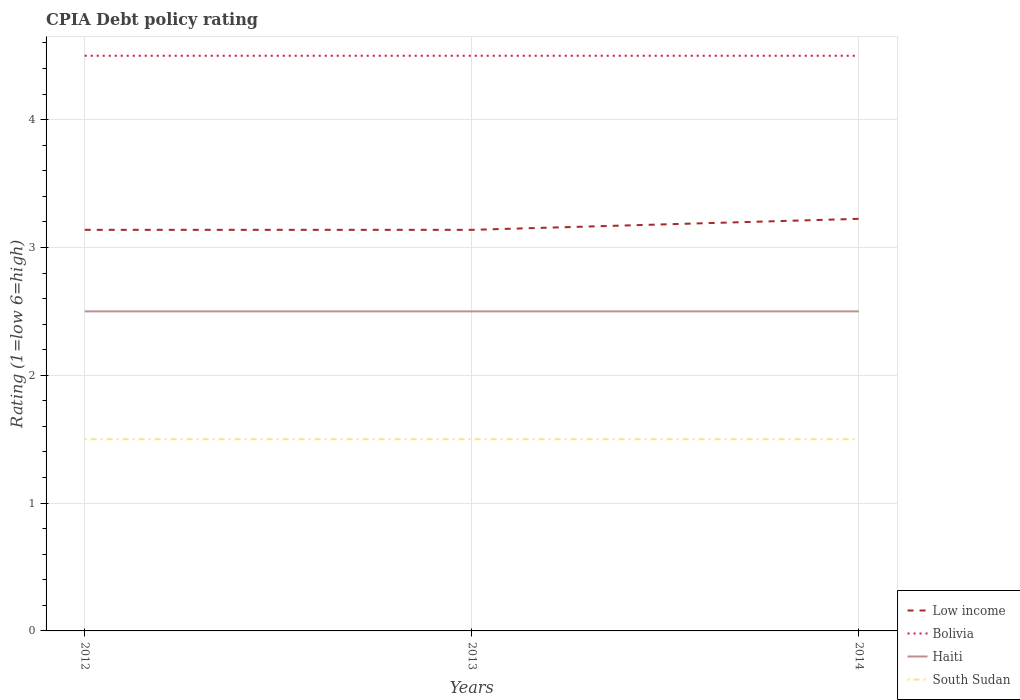Is the number of lines equal to the number of legend labels?
Keep it short and to the point. Yes. Across all years, what is the maximum CPIA rating in South Sudan?
Make the answer very short. 1.5. What is the difference between the highest and the lowest CPIA rating in Bolivia?
Give a very brief answer. 0. Is the CPIA rating in South Sudan strictly greater than the CPIA rating in Bolivia over the years?
Offer a very short reply. Yes. What is the difference between two consecutive major ticks on the Y-axis?
Make the answer very short. 1. Does the graph contain any zero values?
Provide a short and direct response. No. Does the graph contain grids?
Offer a very short reply. Yes. Where does the legend appear in the graph?
Keep it short and to the point. Bottom right. How many legend labels are there?
Your answer should be compact. 4. How are the legend labels stacked?
Your answer should be compact. Vertical. What is the title of the graph?
Offer a terse response. CPIA Debt policy rating. What is the label or title of the X-axis?
Ensure brevity in your answer.  Years. What is the Rating (1=low 6=high) in Low income in 2012?
Your answer should be very brief. 3.14. What is the Rating (1=low 6=high) in Haiti in 2012?
Ensure brevity in your answer.  2.5. What is the Rating (1=low 6=high) in South Sudan in 2012?
Your answer should be compact. 1.5. What is the Rating (1=low 6=high) in Low income in 2013?
Your answer should be very brief. 3.14. What is the Rating (1=low 6=high) of Bolivia in 2013?
Offer a very short reply. 4.5. What is the Rating (1=low 6=high) in Haiti in 2013?
Your answer should be compact. 2.5. What is the Rating (1=low 6=high) in South Sudan in 2013?
Keep it short and to the point. 1.5. What is the Rating (1=low 6=high) of Low income in 2014?
Your answer should be very brief. 3.22. Across all years, what is the maximum Rating (1=low 6=high) of Low income?
Your answer should be compact. 3.22. Across all years, what is the maximum Rating (1=low 6=high) in Bolivia?
Your answer should be compact. 4.5. Across all years, what is the maximum Rating (1=low 6=high) of Haiti?
Keep it short and to the point. 2.5. Across all years, what is the maximum Rating (1=low 6=high) in South Sudan?
Your answer should be compact. 1.5. Across all years, what is the minimum Rating (1=low 6=high) in Low income?
Offer a very short reply. 3.14. Across all years, what is the minimum Rating (1=low 6=high) of South Sudan?
Offer a terse response. 1.5. What is the total Rating (1=low 6=high) in Low income in the graph?
Provide a short and direct response. 9.5. What is the total Rating (1=low 6=high) of Haiti in the graph?
Ensure brevity in your answer.  7.5. What is the difference between the Rating (1=low 6=high) of Low income in 2012 and that in 2013?
Ensure brevity in your answer.  0. What is the difference between the Rating (1=low 6=high) in Bolivia in 2012 and that in 2013?
Make the answer very short. 0. What is the difference between the Rating (1=low 6=high) in Haiti in 2012 and that in 2013?
Keep it short and to the point. 0. What is the difference between the Rating (1=low 6=high) in South Sudan in 2012 and that in 2013?
Offer a terse response. 0. What is the difference between the Rating (1=low 6=high) of Low income in 2012 and that in 2014?
Provide a succinct answer. -0.09. What is the difference between the Rating (1=low 6=high) in Bolivia in 2012 and that in 2014?
Your answer should be very brief. 0. What is the difference between the Rating (1=low 6=high) of Low income in 2013 and that in 2014?
Ensure brevity in your answer.  -0.09. What is the difference between the Rating (1=low 6=high) of South Sudan in 2013 and that in 2014?
Your answer should be very brief. 0. What is the difference between the Rating (1=low 6=high) of Low income in 2012 and the Rating (1=low 6=high) of Bolivia in 2013?
Your response must be concise. -1.36. What is the difference between the Rating (1=low 6=high) of Low income in 2012 and the Rating (1=low 6=high) of Haiti in 2013?
Provide a succinct answer. 0.64. What is the difference between the Rating (1=low 6=high) in Low income in 2012 and the Rating (1=low 6=high) in South Sudan in 2013?
Give a very brief answer. 1.64. What is the difference between the Rating (1=low 6=high) of Bolivia in 2012 and the Rating (1=low 6=high) of Haiti in 2013?
Offer a terse response. 2. What is the difference between the Rating (1=low 6=high) of Bolivia in 2012 and the Rating (1=low 6=high) of South Sudan in 2013?
Your response must be concise. 3. What is the difference between the Rating (1=low 6=high) of Low income in 2012 and the Rating (1=low 6=high) of Bolivia in 2014?
Make the answer very short. -1.36. What is the difference between the Rating (1=low 6=high) of Low income in 2012 and the Rating (1=low 6=high) of Haiti in 2014?
Your answer should be very brief. 0.64. What is the difference between the Rating (1=low 6=high) in Low income in 2012 and the Rating (1=low 6=high) in South Sudan in 2014?
Your response must be concise. 1.64. What is the difference between the Rating (1=low 6=high) of Low income in 2013 and the Rating (1=low 6=high) of Bolivia in 2014?
Give a very brief answer. -1.36. What is the difference between the Rating (1=low 6=high) of Low income in 2013 and the Rating (1=low 6=high) of Haiti in 2014?
Make the answer very short. 0.64. What is the difference between the Rating (1=low 6=high) in Low income in 2013 and the Rating (1=low 6=high) in South Sudan in 2014?
Provide a succinct answer. 1.64. What is the difference between the Rating (1=low 6=high) of Bolivia in 2013 and the Rating (1=low 6=high) of South Sudan in 2014?
Make the answer very short. 3. What is the difference between the Rating (1=low 6=high) of Haiti in 2013 and the Rating (1=low 6=high) of South Sudan in 2014?
Your response must be concise. 1. What is the average Rating (1=low 6=high) of Low income per year?
Ensure brevity in your answer.  3.17. What is the average Rating (1=low 6=high) in Haiti per year?
Your answer should be very brief. 2.5. In the year 2012, what is the difference between the Rating (1=low 6=high) of Low income and Rating (1=low 6=high) of Bolivia?
Your response must be concise. -1.36. In the year 2012, what is the difference between the Rating (1=low 6=high) in Low income and Rating (1=low 6=high) in Haiti?
Your answer should be compact. 0.64. In the year 2012, what is the difference between the Rating (1=low 6=high) of Low income and Rating (1=low 6=high) of South Sudan?
Your answer should be very brief. 1.64. In the year 2012, what is the difference between the Rating (1=low 6=high) of Bolivia and Rating (1=low 6=high) of Haiti?
Your answer should be compact. 2. In the year 2012, what is the difference between the Rating (1=low 6=high) in Haiti and Rating (1=low 6=high) in South Sudan?
Give a very brief answer. 1. In the year 2013, what is the difference between the Rating (1=low 6=high) of Low income and Rating (1=low 6=high) of Bolivia?
Offer a very short reply. -1.36. In the year 2013, what is the difference between the Rating (1=low 6=high) in Low income and Rating (1=low 6=high) in Haiti?
Give a very brief answer. 0.64. In the year 2013, what is the difference between the Rating (1=low 6=high) of Low income and Rating (1=low 6=high) of South Sudan?
Make the answer very short. 1.64. In the year 2013, what is the difference between the Rating (1=low 6=high) in Bolivia and Rating (1=low 6=high) in South Sudan?
Ensure brevity in your answer.  3. In the year 2014, what is the difference between the Rating (1=low 6=high) in Low income and Rating (1=low 6=high) in Bolivia?
Make the answer very short. -1.28. In the year 2014, what is the difference between the Rating (1=low 6=high) of Low income and Rating (1=low 6=high) of Haiti?
Give a very brief answer. 0.72. In the year 2014, what is the difference between the Rating (1=low 6=high) in Low income and Rating (1=low 6=high) in South Sudan?
Provide a short and direct response. 1.72. In the year 2014, what is the difference between the Rating (1=low 6=high) in Bolivia and Rating (1=low 6=high) in Haiti?
Ensure brevity in your answer.  2. What is the ratio of the Rating (1=low 6=high) of Bolivia in 2012 to that in 2013?
Your answer should be compact. 1. What is the ratio of the Rating (1=low 6=high) in South Sudan in 2012 to that in 2013?
Your answer should be compact. 1. What is the ratio of the Rating (1=low 6=high) in Low income in 2012 to that in 2014?
Your answer should be compact. 0.97. What is the ratio of the Rating (1=low 6=high) in Haiti in 2012 to that in 2014?
Give a very brief answer. 1. What is the ratio of the Rating (1=low 6=high) of South Sudan in 2012 to that in 2014?
Your response must be concise. 1. What is the ratio of the Rating (1=low 6=high) in Low income in 2013 to that in 2014?
Provide a short and direct response. 0.97. What is the ratio of the Rating (1=low 6=high) in Bolivia in 2013 to that in 2014?
Offer a terse response. 1. What is the ratio of the Rating (1=low 6=high) of Haiti in 2013 to that in 2014?
Your answer should be compact. 1. What is the ratio of the Rating (1=low 6=high) of South Sudan in 2013 to that in 2014?
Give a very brief answer. 1. What is the difference between the highest and the second highest Rating (1=low 6=high) in Low income?
Your answer should be compact. 0.09. What is the difference between the highest and the second highest Rating (1=low 6=high) of Haiti?
Provide a succinct answer. 0. What is the difference between the highest and the lowest Rating (1=low 6=high) of Low income?
Provide a short and direct response. 0.09. 